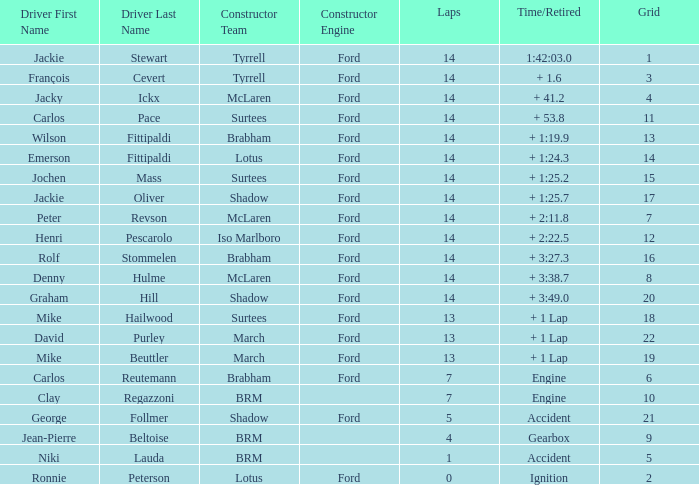What is the low lap total for henri pescarolo with a grad larger than 6? 14.0. 